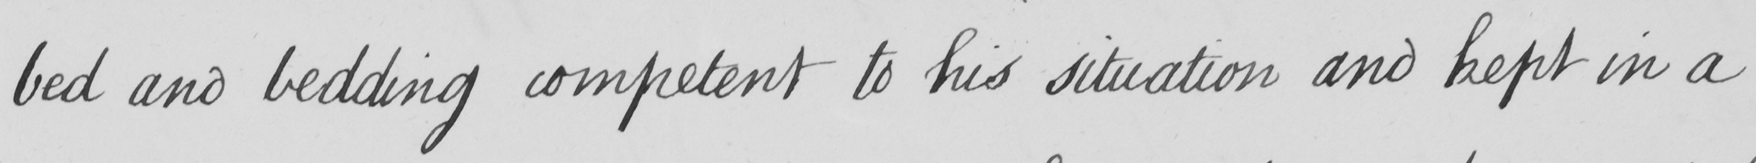Can you read and transcribe this handwriting? bed and bedding competent to his situation and kept in a 